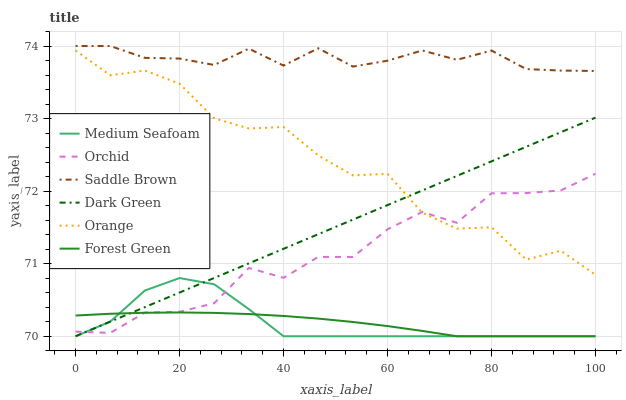Does Forest Green have the minimum area under the curve?
Answer yes or no. Yes. Does Orange have the minimum area under the curve?
Answer yes or no. No. Does Orange have the maximum area under the curve?
Answer yes or no. No. Is Orange the roughest?
Answer yes or no. Yes. Is Forest Green the smoothest?
Answer yes or no. No. Is Forest Green the roughest?
Answer yes or no. No. Does Orange have the lowest value?
Answer yes or no. No. Does Orange have the highest value?
Answer yes or no. No. Is Forest Green less than Orange?
Answer yes or no. Yes. Is Orange greater than Medium Seafoam?
Answer yes or no. Yes. Does Forest Green intersect Orange?
Answer yes or no. No. 